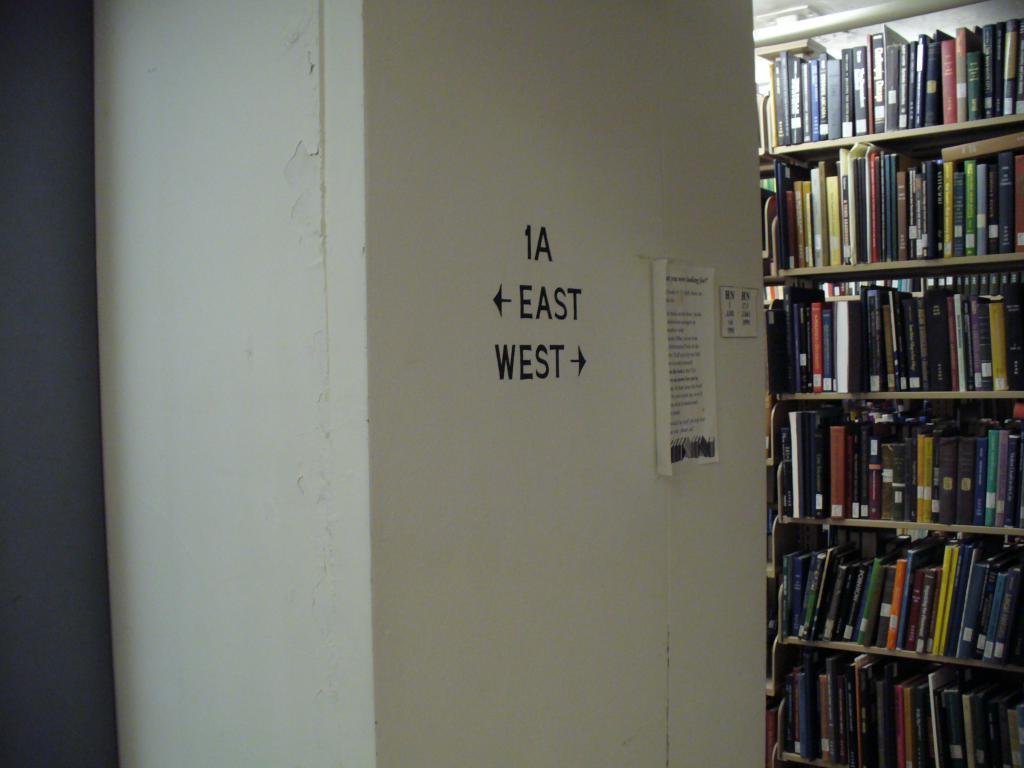Please provide a concise description of this image. In this picture there is a wall in the center of the image and there is a bookshelf on the right side of the image, there is a poster on the wall. 